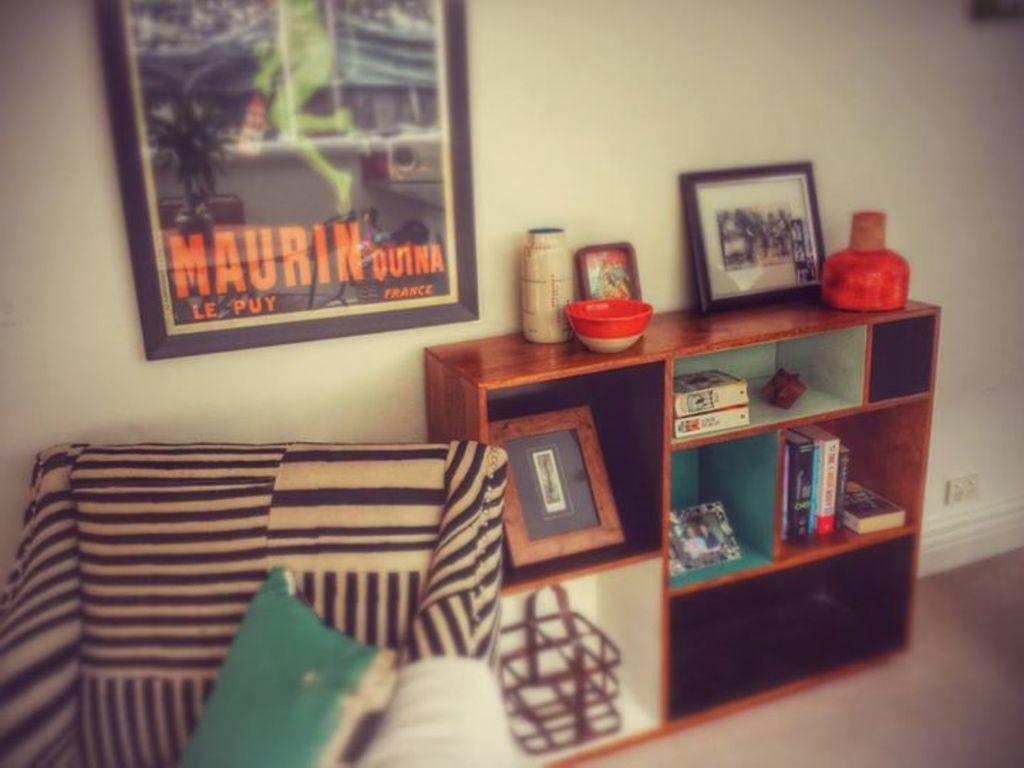<image>
Create a compact narrative representing the image presented. A Maurin Quina Le Puy poster is framed and hanging on a wall next to a bookshelf with a black and white striped chair in front of it. 